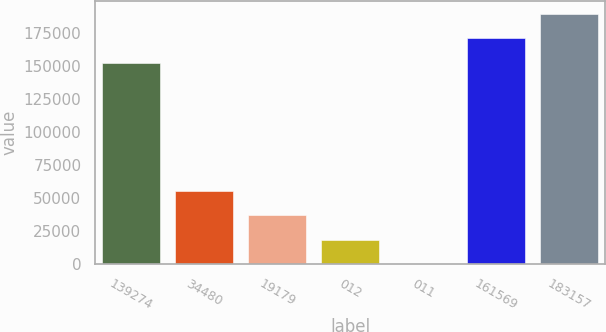Convert chart. <chart><loc_0><loc_0><loc_500><loc_500><bar_chart><fcel>139274<fcel>34480<fcel>19179<fcel>012<fcel>011<fcel>161569<fcel>183157<nl><fcel>152654<fcel>55680.4<fcel>37120.3<fcel>18560.2<fcel>0.12<fcel>171214<fcel>189774<nl></chart> 